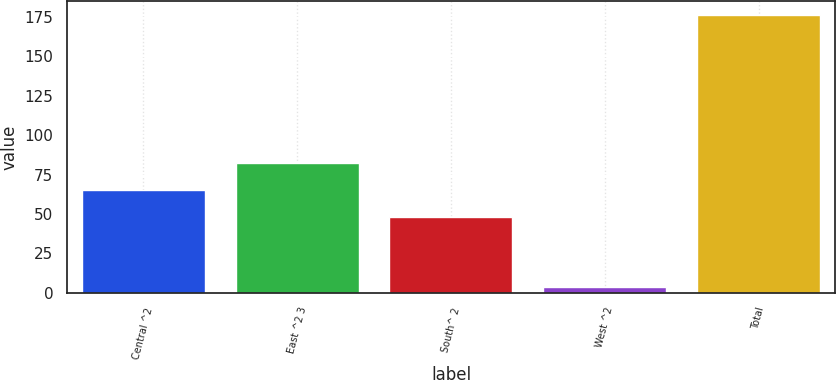Convert chart to OTSL. <chart><loc_0><loc_0><loc_500><loc_500><bar_chart><fcel>Central ^2<fcel>East ^2 3<fcel>South^ 2<fcel>West ^2<fcel>Total<nl><fcel>65.2<fcel>82.4<fcel>48<fcel>4<fcel>176<nl></chart> 